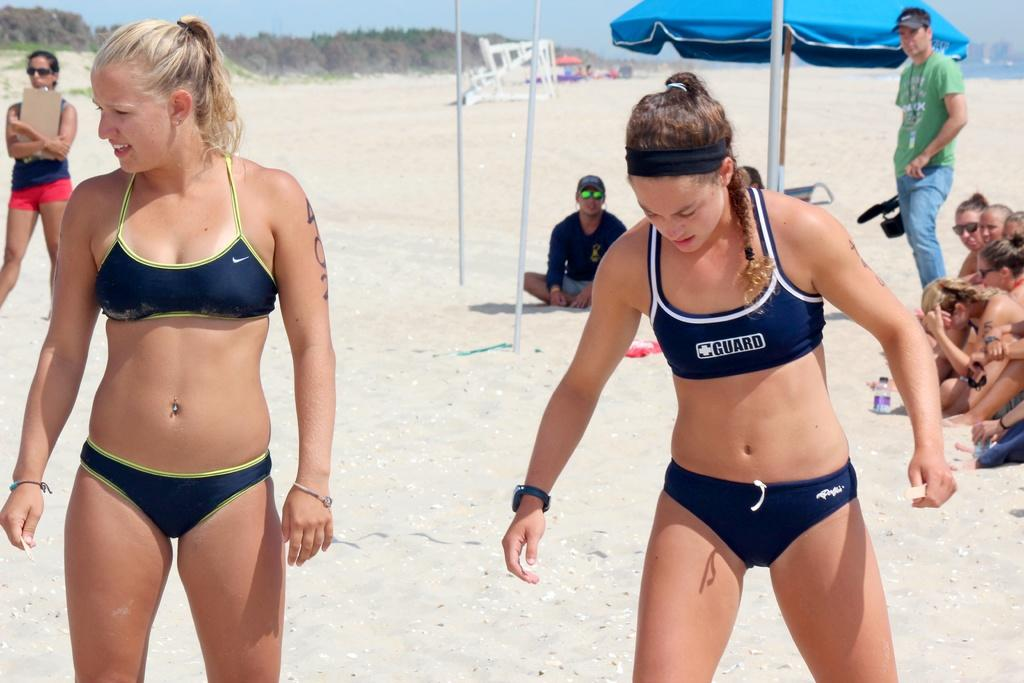<image>
Relay a brief, clear account of the picture shown. A woman has the word guard on her bathing suit top. 